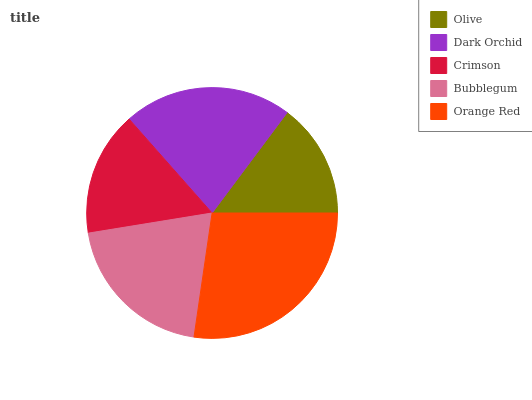Is Olive the minimum?
Answer yes or no. Yes. Is Orange Red the maximum?
Answer yes or no. Yes. Is Dark Orchid the minimum?
Answer yes or no. No. Is Dark Orchid the maximum?
Answer yes or no. No. Is Dark Orchid greater than Olive?
Answer yes or no. Yes. Is Olive less than Dark Orchid?
Answer yes or no. Yes. Is Olive greater than Dark Orchid?
Answer yes or no. No. Is Dark Orchid less than Olive?
Answer yes or no. No. Is Bubblegum the high median?
Answer yes or no. Yes. Is Bubblegum the low median?
Answer yes or no. Yes. Is Dark Orchid the high median?
Answer yes or no. No. Is Crimson the low median?
Answer yes or no. No. 